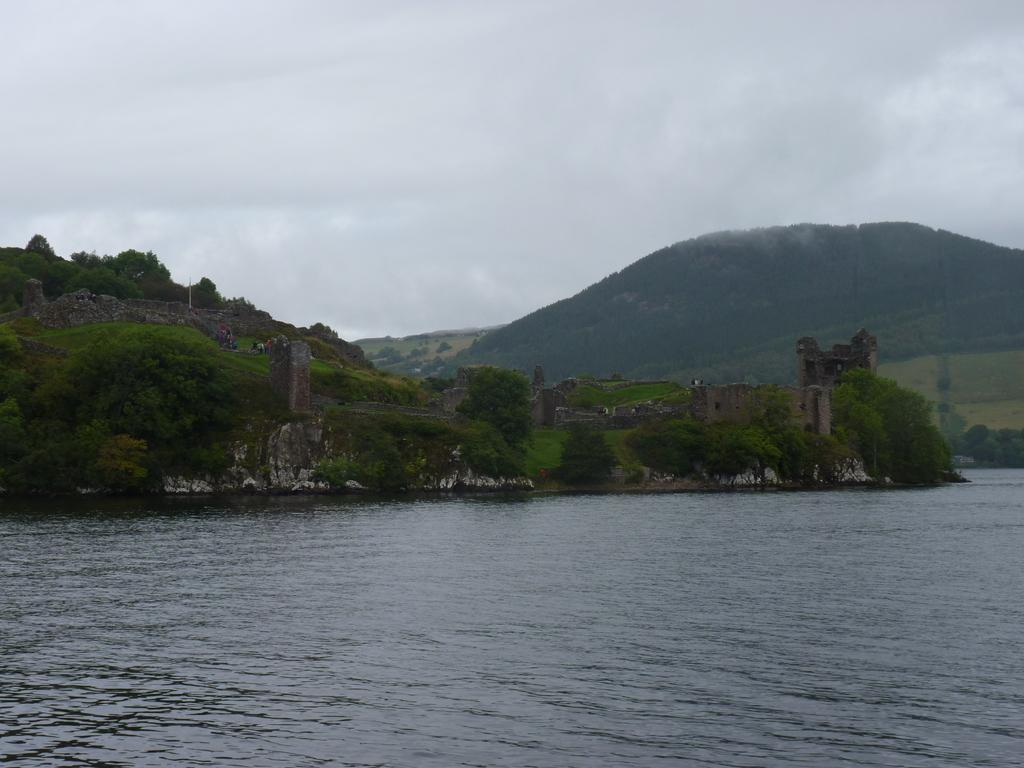What is the main feature in the foreground of the picture? There is a water body in the foreground of the picture. What can be seen in the center of the picture? There are hills, grasslands, and trees in the center of the picture. What is the condition of the sky in the picture? The sky is cloudy in the picture. Where is the linen plantation located in the image? There is no linen plantation present in the image. What type of plant can be seen growing in the grasslands? The provided facts do not mention any specific plants growing in the grasslands. 